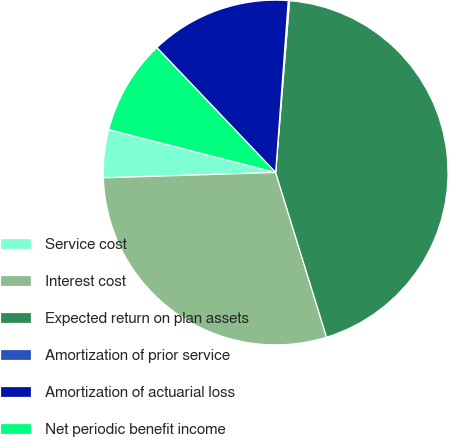Convert chart to OTSL. <chart><loc_0><loc_0><loc_500><loc_500><pie_chart><fcel>Service cost<fcel>Interest cost<fcel>Expected return on plan assets<fcel>Amortization of prior service<fcel>Amortization of actuarial loss<fcel>Net periodic benefit income<nl><fcel>4.5%<fcel>29.28%<fcel>43.94%<fcel>0.12%<fcel>13.27%<fcel>8.89%<nl></chart> 